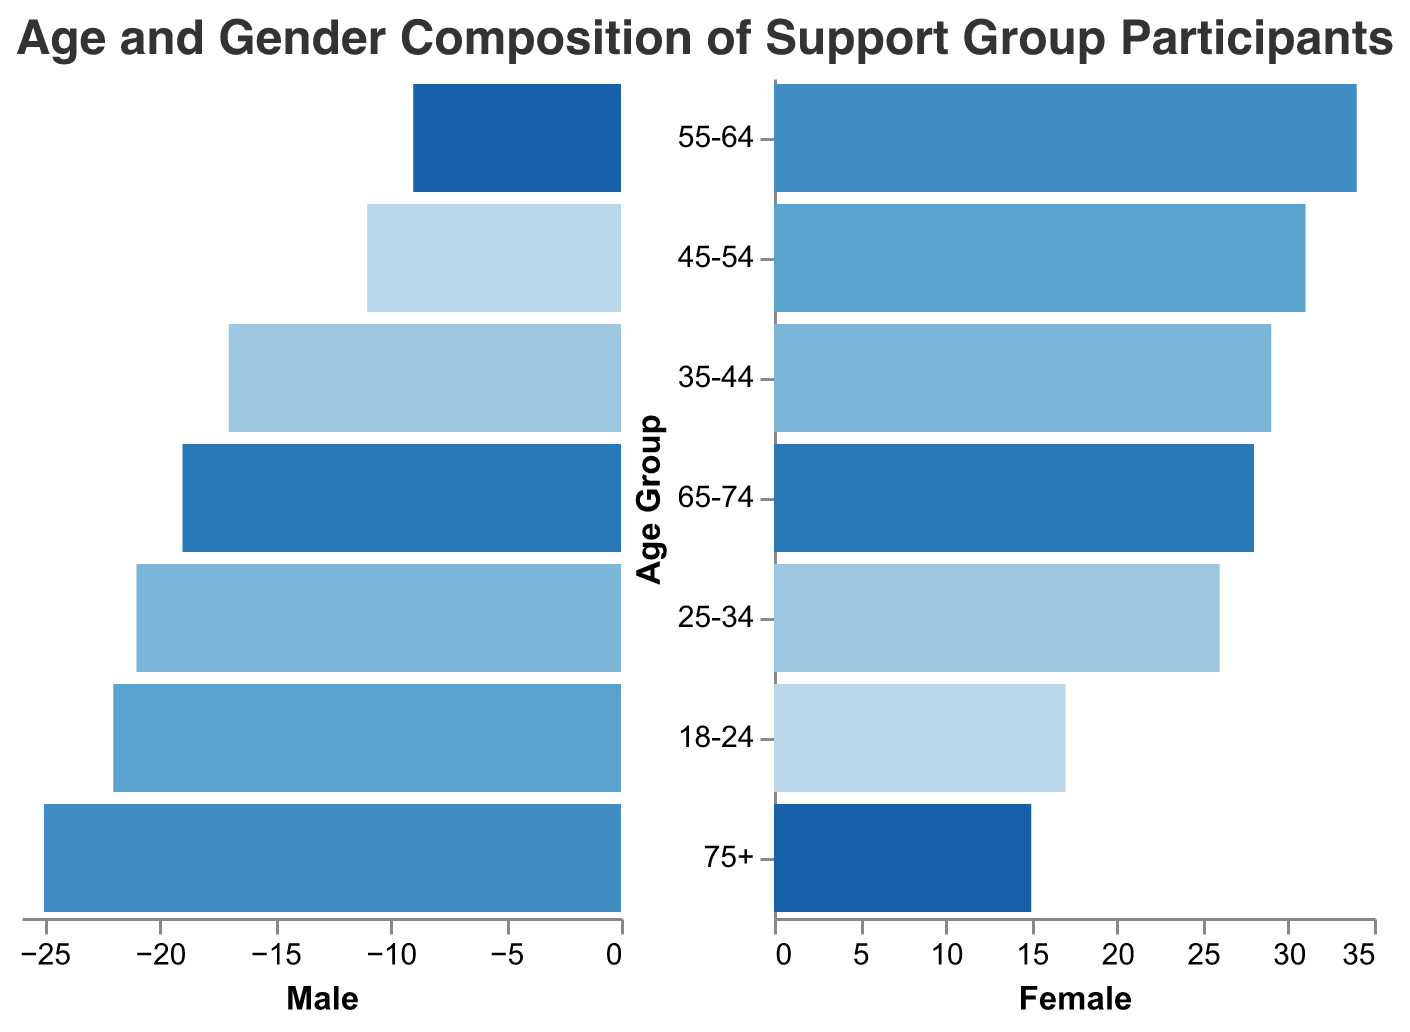Which age group of long-term participants has the highest number of females? By looking at the "Long-term Female" data, the age group 55-64 has the highest value (28).
Answer: 55-64 Which gender and age group have the least number of newcomers? When considering both genders, the newcomer males aged 75+ have the smallest number (1).
Answer: 75+, Male What is the total number of male participants in the age group 35-44? The sum of "Long-term Male" (12) and "Newcomer Male" (9) participants gives 12 + 9 = 21 males.
Answer: 21 What is the difference in the number of long-term participants between males and females aged 45-54? Subtract the number of long-term males (15) from the long-term females (22), resulting in 22 - 15 = 7.
Answer: 7 What age group has the highest number of females in total? By summing "Long-term Female" and "Newcomer Female" for each age group and comparing, the age group with the highest total is 55-64 with a total of 34 (28 + 6).
Answer: 55-64 How many more newcomers aged 18-24 are there compared to long-term participants in the same age group? Adding "Newcomer Male" (8) and "Newcomer Female" (12) gives us 20 newcomers. Adding "Long-term Male" (3) and "Long-term Female" (5) gives us 8 long-term participants. The difference is 20 - 8 = 12.
Answer: 12 Which age group has the smallest total number of participants, both new and long-term? Summing both genders for each age group, 75+ has the lowest number of participants, totaling 24 (8+13+1+2).
Answer: 75+ How does the number of long-term female participants aged 55-64 compare to the number of newcomer female participants in the same age group? There are 28 long-term females and 6 newcomer females aged 55-64, with 28 being significantly higher than 6.
Answer: Long-term has more What is the total number of participants aged 65-74? Summing all entries for males and females, long-term and newcomers for 65-74: 16 (long-term male) + 24 (long-term female) + 3 (newcomer male) + 4 (newcomer female) = 47.
Answer: 47 